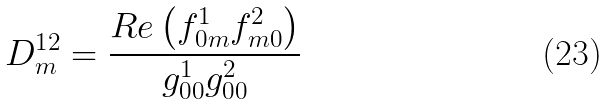<formula> <loc_0><loc_0><loc_500><loc_500>D ^ { 1 2 } _ { m } = \frac { R e \left ( f ^ { 1 } _ { 0 m } f ^ { 2 } _ { m 0 } \right ) } { g ^ { 1 } _ { 0 0 } g ^ { 2 } _ { 0 0 } }</formula> 